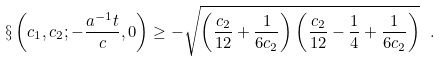Convert formula to latex. <formula><loc_0><loc_0><loc_500><loc_500>\S \left ( c _ { 1 } , c _ { 2 } ; - \frac { a ^ { - 1 } t } { c } , 0 \right ) \geq - \sqrt { \left ( \frac { c _ { 2 } } { 1 2 } + \frac { 1 } { 6 c _ { 2 } } \right ) \left ( \frac { c _ { 2 } } { 1 2 } - \frac { 1 } { 4 } + \frac { 1 } { 6 c _ { 2 } } \right ) } \ .</formula> 